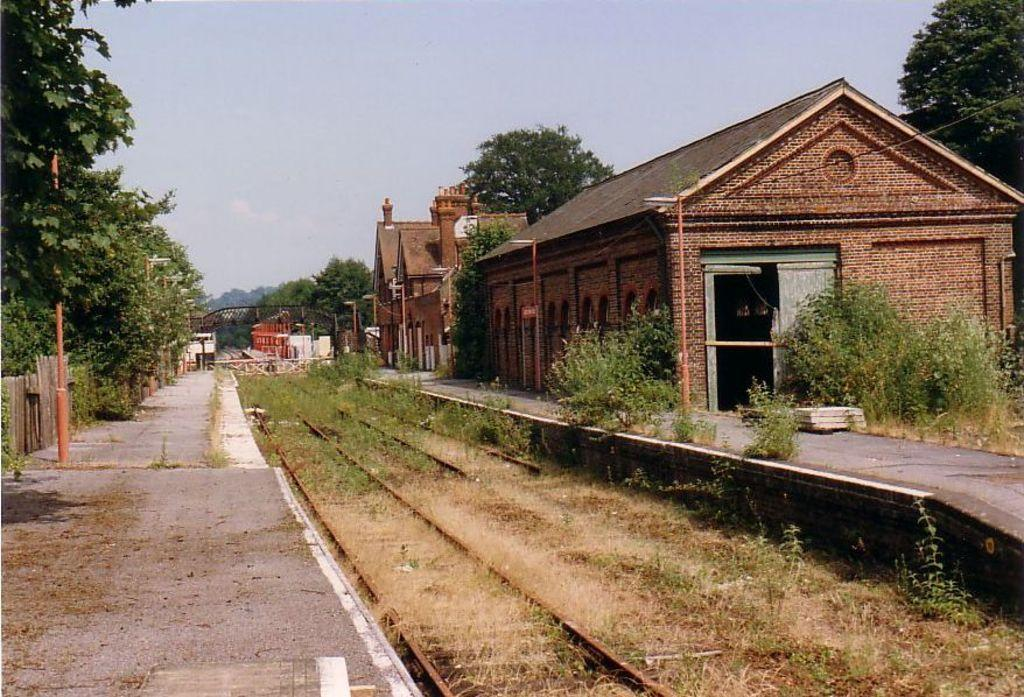What is located in the middle of the image? There is a rail track in the middle of the image. What can be seen on the right side of the image? There is a building on the right side of the image. What is on the left side of the image? There is a platform on the left side of the image. What type of vegetation is visible behind the rail track? Trees are visible behind the rail track on either side. What is visible above the rail track? The sky is visible above the rail track. What type of copper material is used to build the rail track in the image? There is no mention of copper or any specific material used to build the rail track in the image. Can you tell me how many cakes are on the platform in the image? There is no mention of cakes or any food items on the platform in the image. 